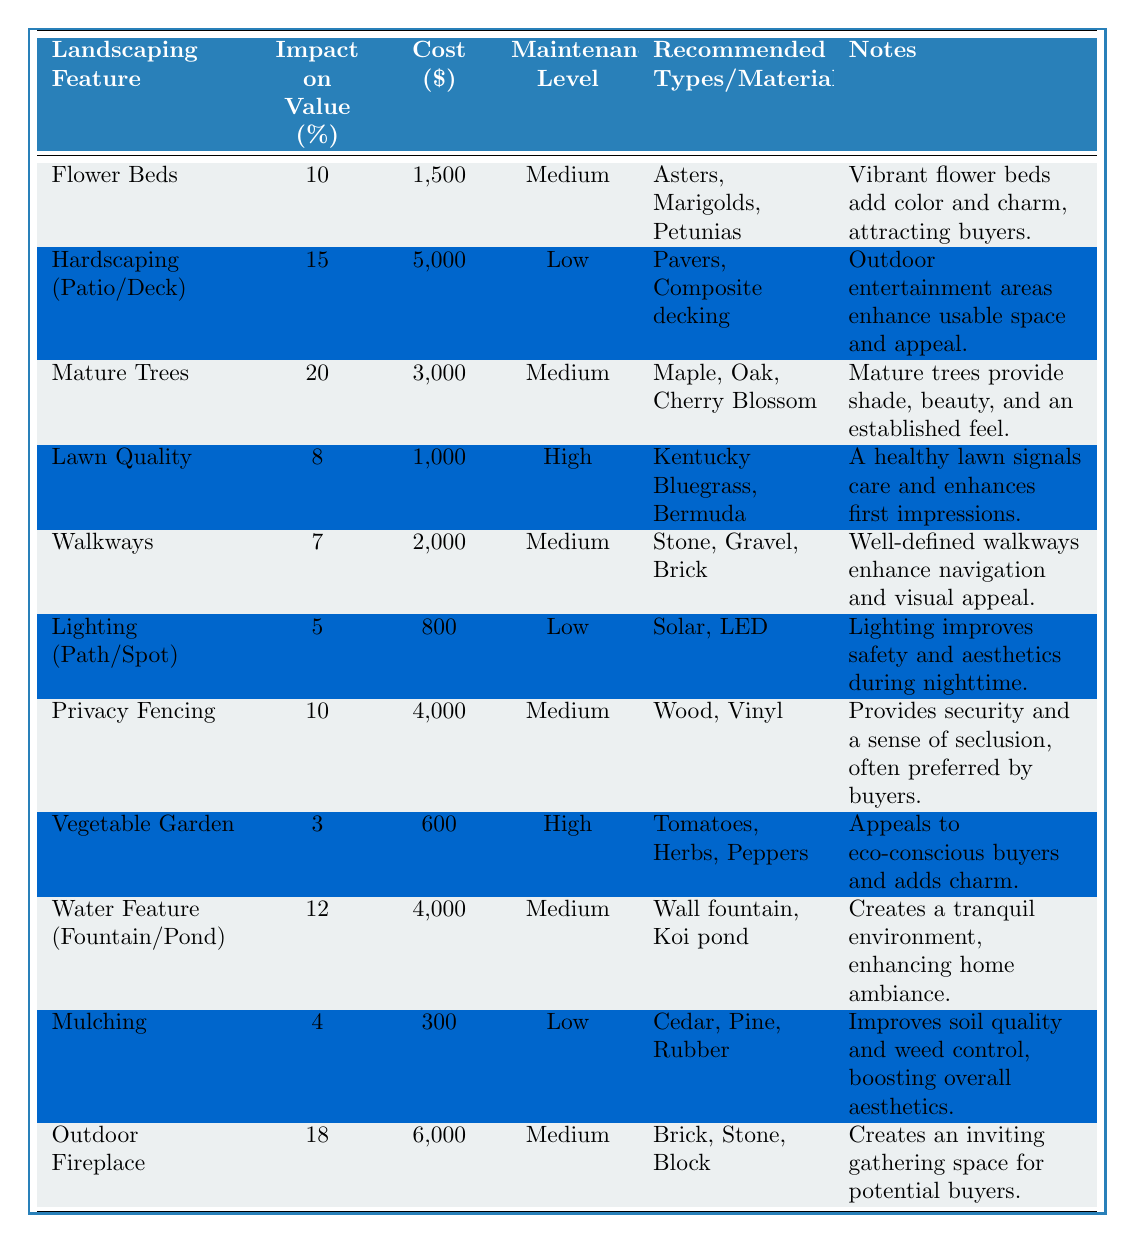What is the landscaping feature with the highest impact on property value? The table shows that "Mature Trees" have the highest impact on value at 20%.
Answer: Mature Trees What is the total cost of installing an Outdoor Fireplace and a Hardscaping feature? The cost of the Outdoor Fireplace is $6,000 and the cost of the Hardscaping feature is $5,000. Adding these together gives $6,000 + $5,000 = $11,000.
Answer: $11,000 How many landscaping features have a low maintenance level? Looking through the table, there are three features listed under low maintenance: Hardscaping, Lighting, and Mulching. Therefore, the count is 3.
Answer: 3 Is the impact on property value of a Vegetable Garden higher than a Water Feature? The Vegetable Garden has an impact of 3% while the Water Feature has an impact of 12%. Since 3% is less than 12%, the statement is false.
Answer: No What is the average cost of all the landscaping features listed? First, the total cost is calculated by adding all the costs: (1500 + 5000 + 3000 + 1000 + 2000 + 800 + 4000 + 600 + 4000 + 300 + 6000) = 25,000. There are 10 features, so the average cost is $25,000 / 10 = $2,500.
Answer: $2,500 Which landscaping feature has the lowest impact on property value? The feature with the lowest impact is the Vegetable Garden at 3%.
Answer: Vegetable Garden What is the difference in impact on value between an Outdoor Fireplace and a Lawn Quality feature? The Outdoor Fireplace has an impact of 18% while Lawn Quality has an impact of 8%. The difference is 18% - 8% = 10%.
Answer: 10% Is the maintenance level for Flower Beds classified as high? The maintenance level for Flower Beds is medium, which does not qualify as high. Thus, the answer is false.
Answer: No Which landscaping feature offers the best value in terms of impact to cost ratio? To find the best ratio, we divide the impact percentage by cost for each feature. The highest ratio is for Mature Trees, which is 20% / 3000 = 0.00667, compared to others. Thus, it offers the best impact to cost return.
Answer: Mature Trees What landscaping features have an impact of 10% or greater? The features with 10% or greater impact are: Mature Trees (20%), Hardscaping (15%), Outdoor Fireplace (18%), and Flower Beds (10%). So, the answer is four features.
Answer: 4 